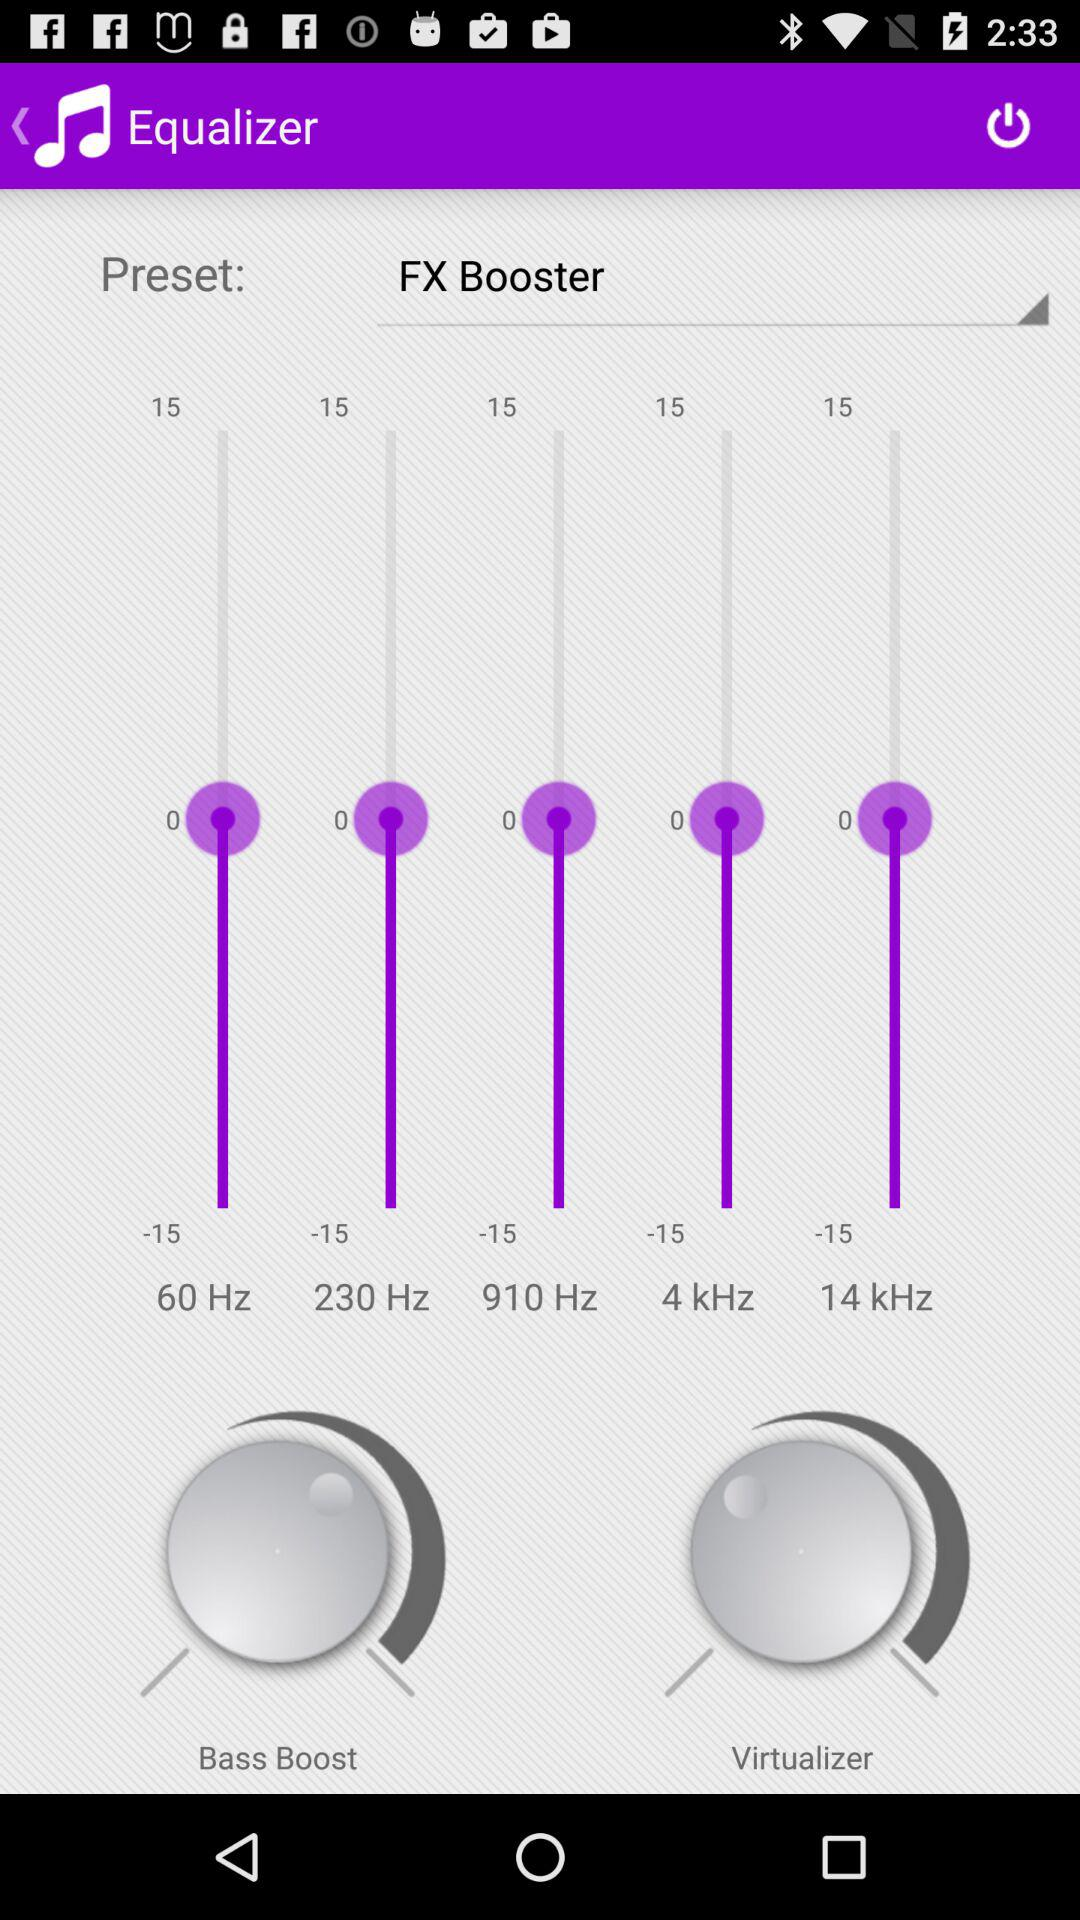What is the shown frequency range? The frequency ranges are 60 Hz, 230 Hz, 910 Hz, 4 kHz and 14 kHz. 